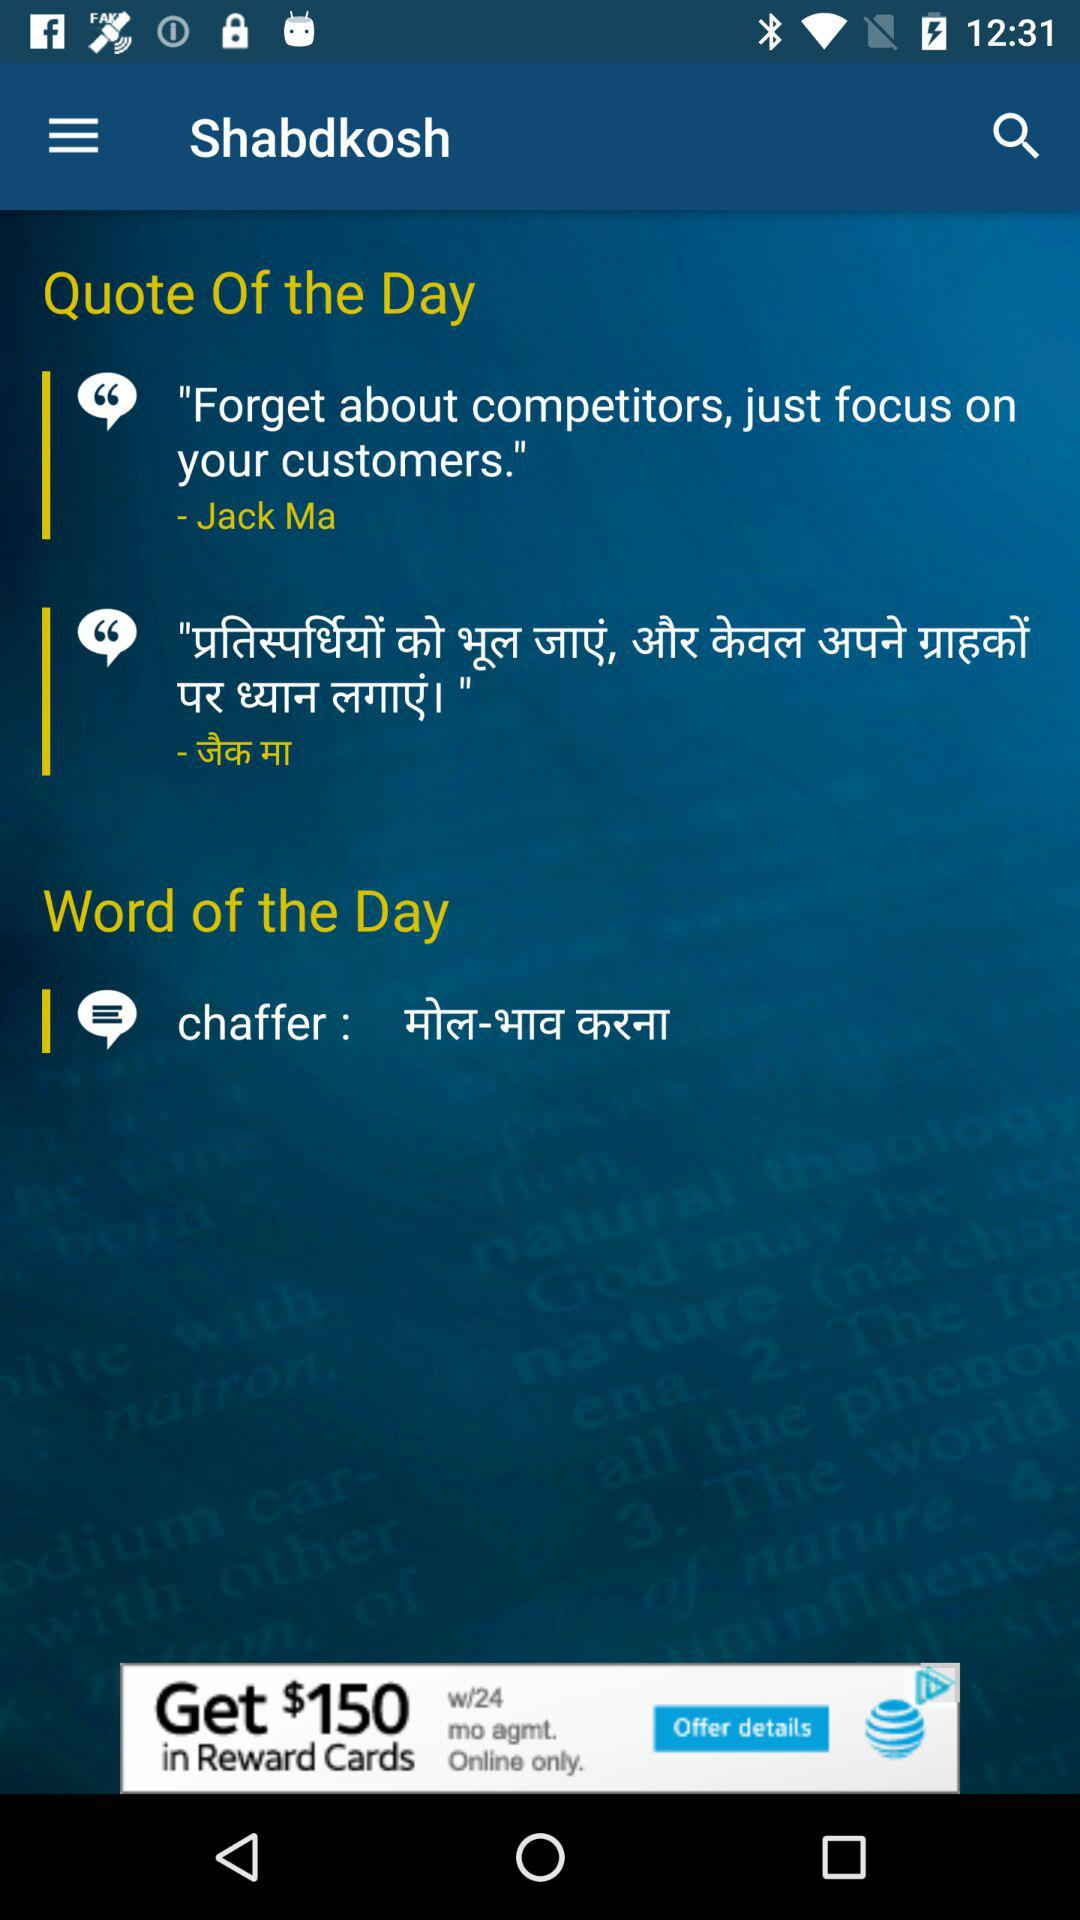How many quotes are there?
Answer the question using a single word or phrase. 2 